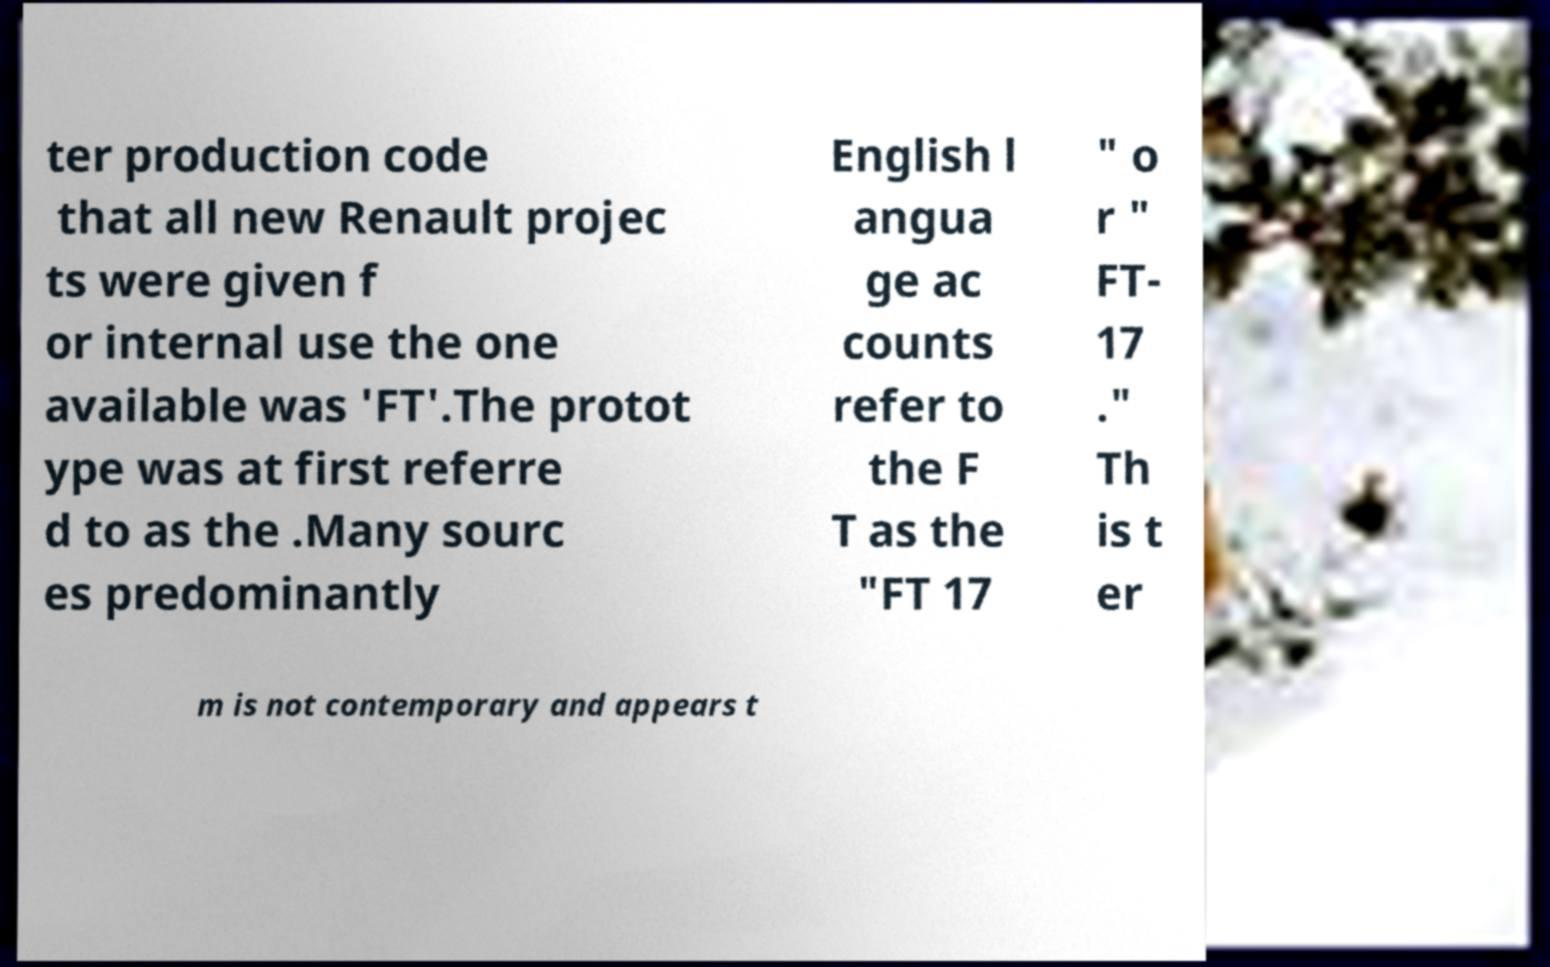Please read and relay the text visible in this image. What does it say? ter production code that all new Renault projec ts were given f or internal use the one available was 'FT'.The protot ype was at first referre d to as the .Many sourc es predominantly English l angua ge ac counts refer to the F T as the "FT 17 " o r " FT- 17 ." Th is t er m is not contemporary and appears t 